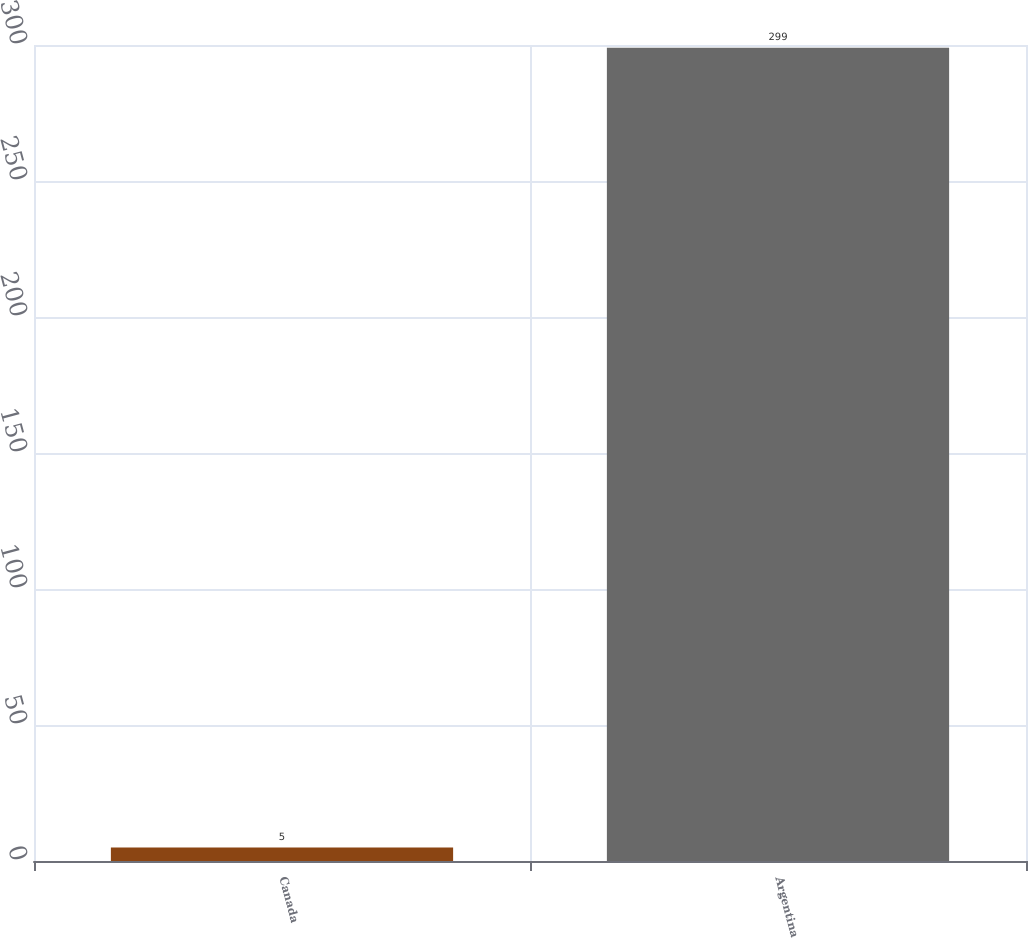<chart> <loc_0><loc_0><loc_500><loc_500><bar_chart><fcel>Canada<fcel>Argentina<nl><fcel>5<fcel>299<nl></chart> 